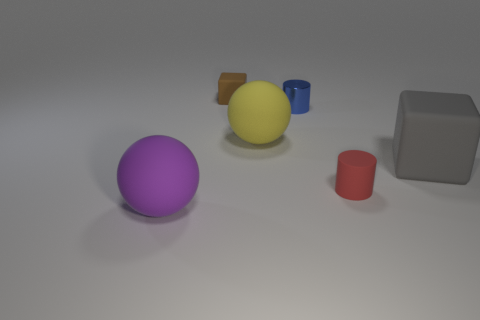Add 2 large blue matte cylinders. How many objects exist? 8 Subtract all balls. How many objects are left? 4 Add 2 blue metal objects. How many blue metal objects are left? 3 Add 6 gray balls. How many gray balls exist? 6 Subtract 0 green balls. How many objects are left? 6 Subtract all gray objects. Subtract all big gray rubber things. How many objects are left? 4 